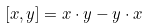<formula> <loc_0><loc_0><loc_500><loc_500>[ x , y ] = x \cdot y - y \cdot x</formula> 